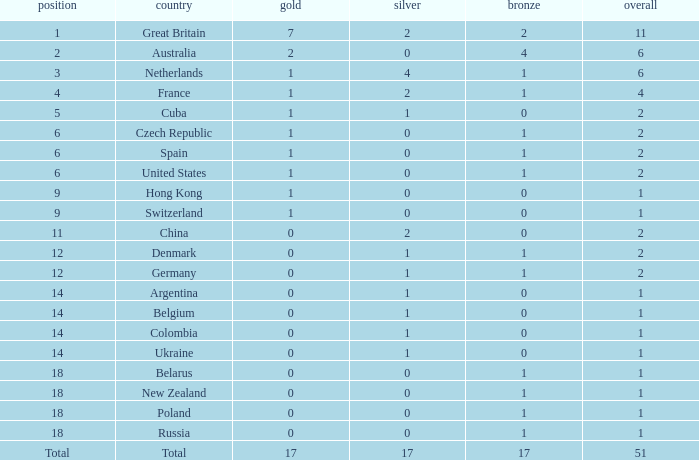Tell me the lowest gold for rank of 6 and total less than 2 None. 